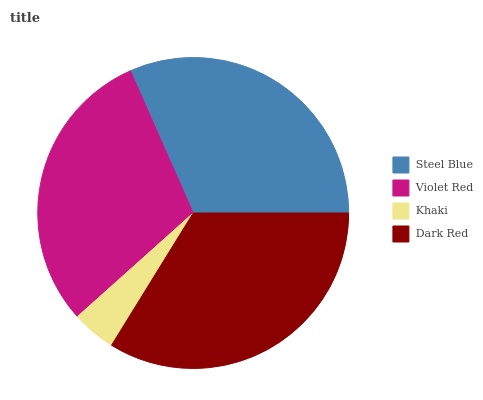Is Khaki the minimum?
Answer yes or no. Yes. Is Dark Red the maximum?
Answer yes or no. Yes. Is Violet Red the minimum?
Answer yes or no. No. Is Violet Red the maximum?
Answer yes or no. No. Is Steel Blue greater than Violet Red?
Answer yes or no. Yes. Is Violet Red less than Steel Blue?
Answer yes or no. Yes. Is Violet Red greater than Steel Blue?
Answer yes or no. No. Is Steel Blue less than Violet Red?
Answer yes or no. No. Is Steel Blue the high median?
Answer yes or no. Yes. Is Violet Red the low median?
Answer yes or no. Yes. Is Khaki the high median?
Answer yes or no. No. Is Dark Red the low median?
Answer yes or no. No. 